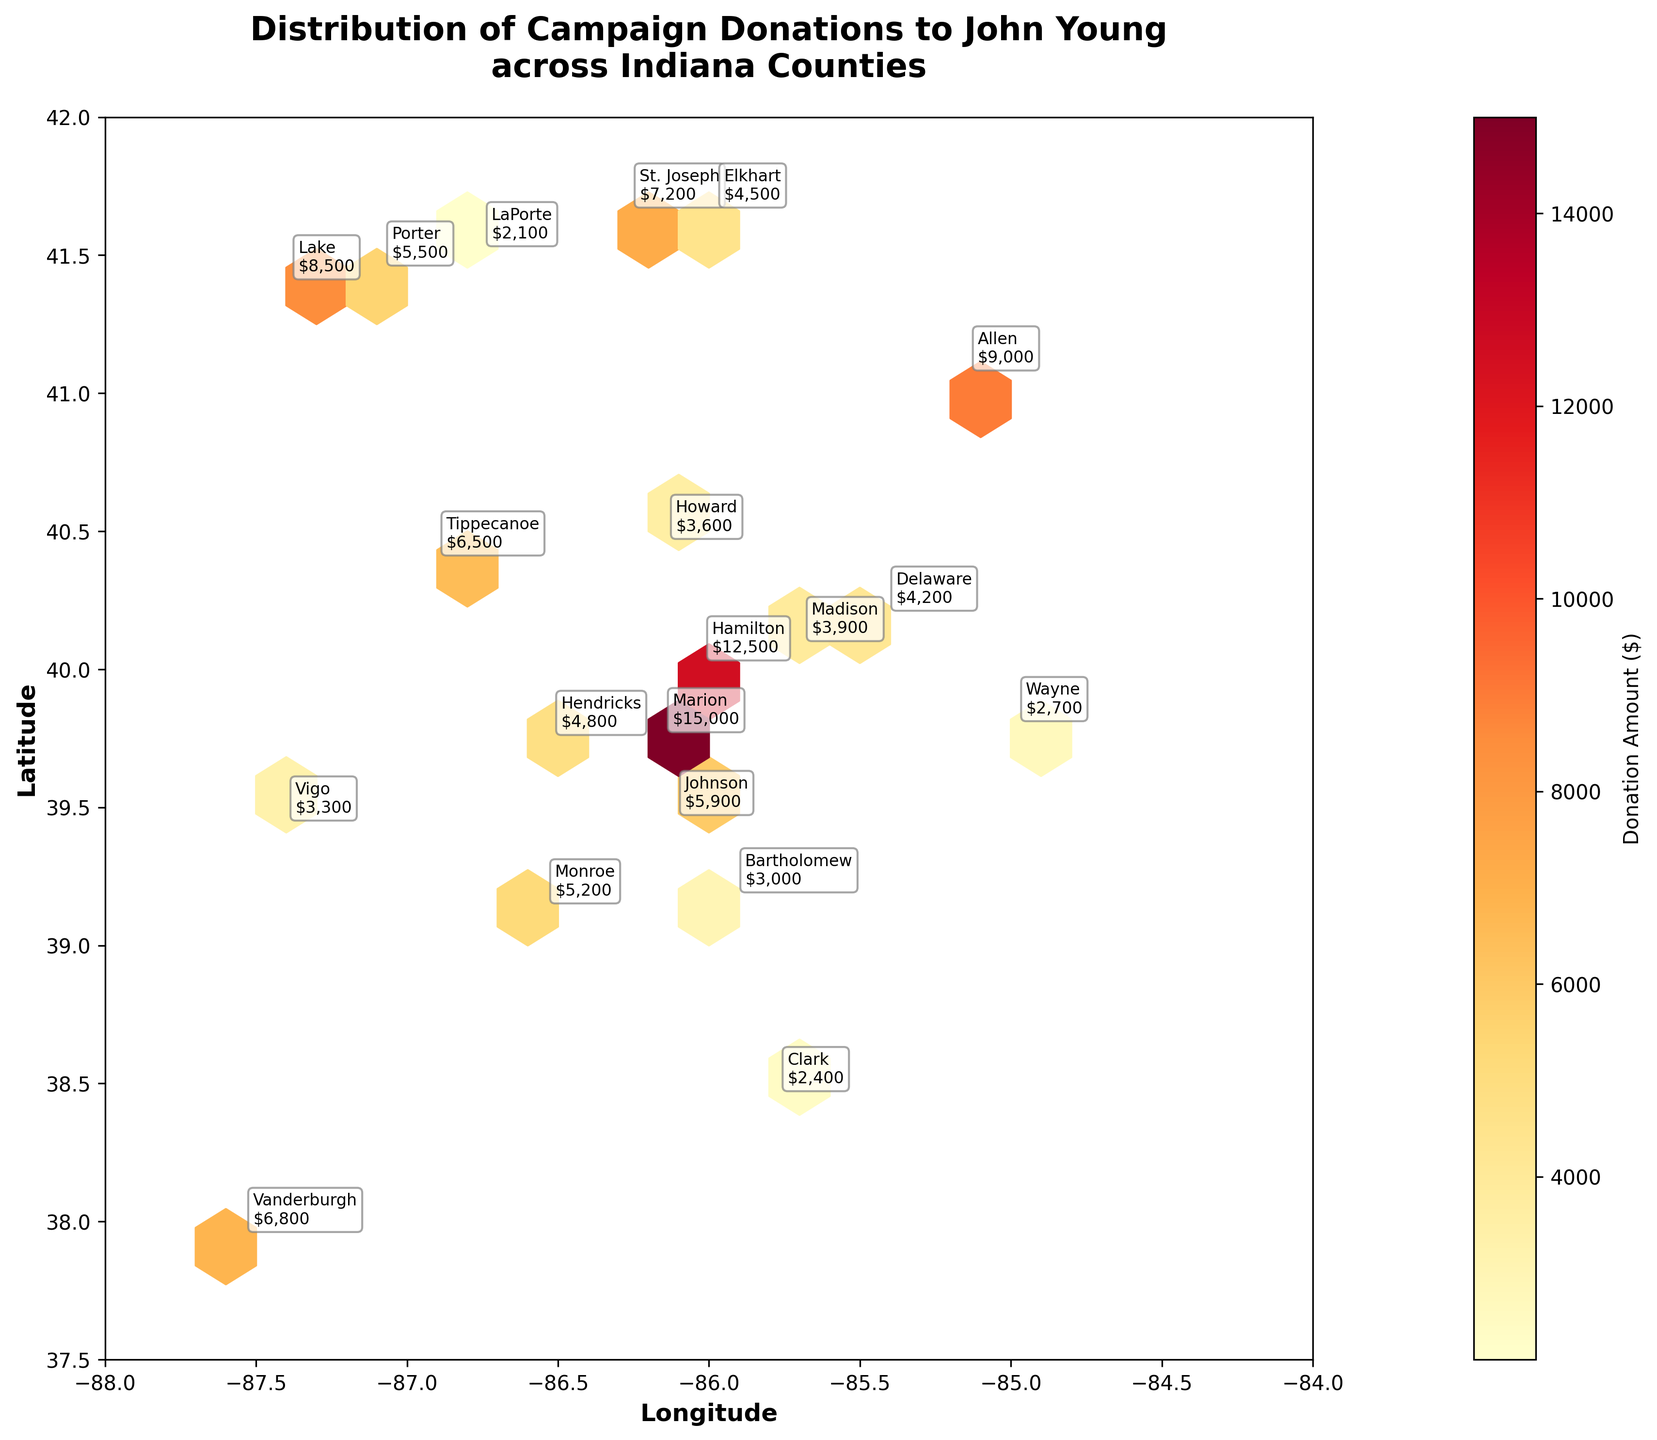what is the title of the plot? The title is the text displayed prominently at the top of the plot, which summarizes the content of the figure. The title in this plot reads "Distribution of Campaign Donations to John Young across Indiana Counties".
Answer: Distribution of Campaign Donations to John Young across Indiana Counties what does the color within each hexbin represent? In the hexbin plot, the color within each hexbin represents the total donation amount, with darker colors indicating higher donations. This is also noted in the color bar labeled "Donation Amount ($)".
Answer: Donation Amount ($) which county has the highest donation amount and what is it? By looking at the annotations on the plot, Marion County has the highest donation amount, because it is labeled with $15,000.
Answer: Marion, $15,000 what are the longitude and latitude ranges displayed on the axes? The x-axis (Longitude) ranges from -88 to -84, and the y-axis (Latitude) ranges from 37.5 to 42, which is evident from the axis tick labels.
Answer: Longitude: -88 to -84, Latitude: 37.5 to 42 how many counties have a donation amount above $10,000? By examining the annotations on the plot, we can see that there are two counties with donation amounts above $10,000: Marion ($15,000) and Hamilton ($12,500).
Answer: 2 which county has the lowest donation amount and what is it? According to the plot annotations, LaPorte County has the lowest donation amount, which is labeled as $2,100.
Answer: LaPorte, $2,100 are there more counties with donations below or above $5,000? By counting the number of counties with annotations labeled below and above $5,000, we see there are 11 counties with donations below $5,000 and 9 counties with donations above $5,000.
Answer: Below $5,000 is there a correlation between geographic location and donation amount? By observing the plot, we can see that counties with higher donations (Marion, Hamilton) are geographically dispersed, suggesting no clear geographic correlation with donation amount.
Answer: No clear correlation which county is closest to the median latitude? To find the median latitude, we list the counties by latitude and find the middle value. The sorted latitudes are 37.97, 38.48, 39.16, 39.20, 39.46, 39.48, 39.77, 39.78, 40.04, 40.11, 40.22, 40.42, 40.48, 41.09, 41.42, 41.47, 41.54, 41.68, 41.68. The median latitude is 40.22, which is Delaware County.
Answer: Delaware 